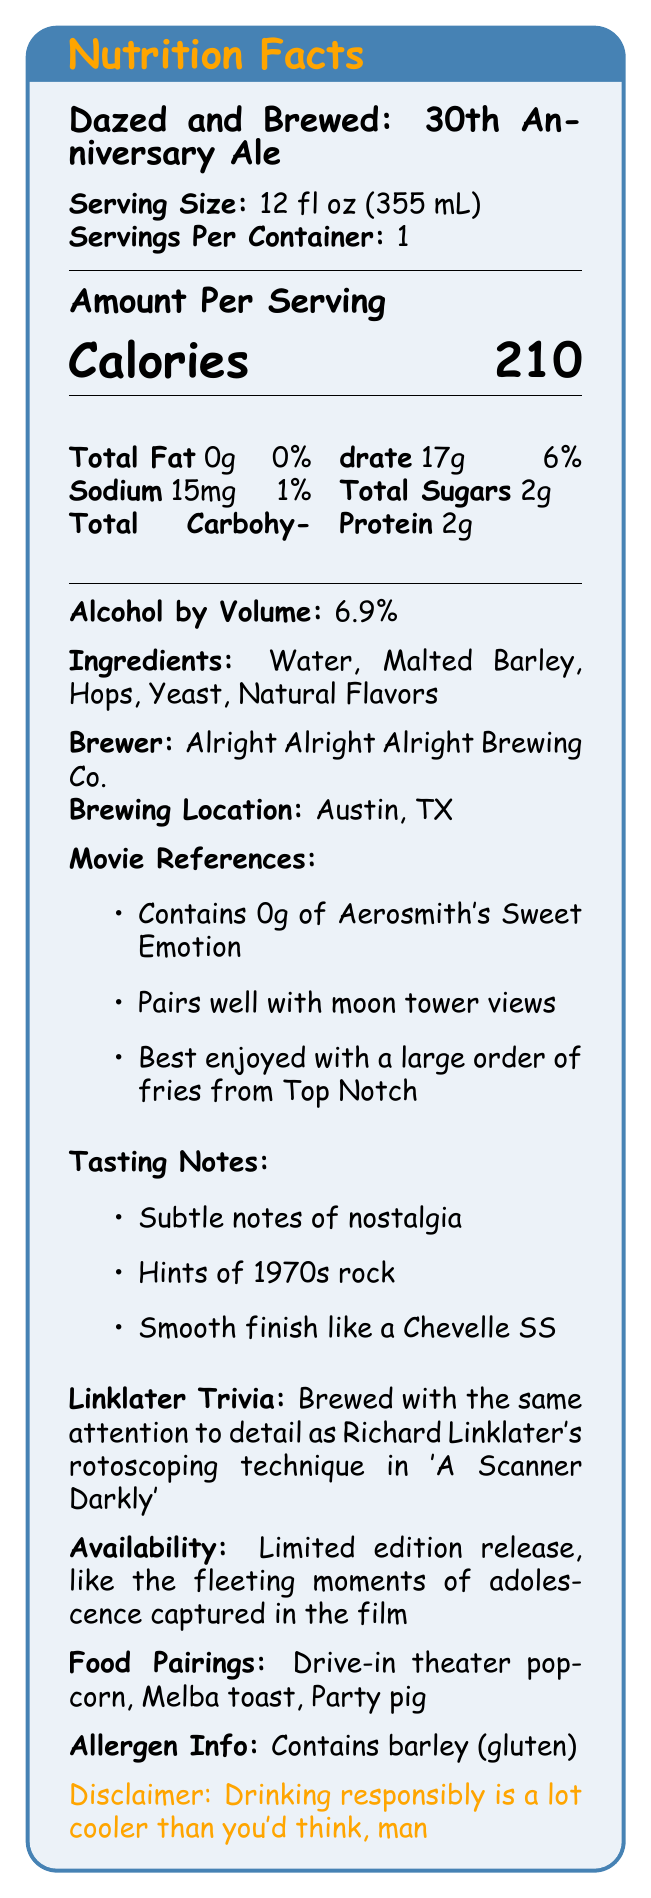what is the serving size for "Dazed and Brewed: 30th Anniversary Ale"? The serving size is listed as "12 fl oz (355 mL)" in the document under the section "Serving Size".
Answer: 12 fl oz (355 mL) how many servings are in each container of this craft beer? The document states that there is 1 serving per container under the section "Servings Per Container".
Answer: 1 how many calories are in one serving of "Dazed and Brewed: 30th Anniversary Ale"? The number of calories is shown in large font under the section "Amount Per Serving".
Answer: 210 what are the ingredients of this craft beer? The ingredients are listed under the section "Ingredients".
Answer: Water, Malted Barley, Hops, Yeast, Natural Flavors who is the brewer of "Dazed and Brewed: 30th Anniversary Ale"? The brewer is listed under the section "Brewer".
Answer: Alright Alright Alright Brewing Co. what is the alcohol by volume (ABV) of this ale? A. 5.0% B. 6.9% C. 7.5% The alcohol by volume is listed as 6.9% in the document under the section "Alcohol by Volume".
Answer: B which city is "Dazed and Brewed: 30th Anniversary Ale" brewed in? A. Houston, TX B. Dallas, TX C. Austin, TX The brewing location is listed as Austin, TX under the section "Brewing Location".
Answer: C which movie reference is not mentioned for this beer? A. Pairs well with moon tower views B. Best enjoyed with a large order of fries from Top Notch C. Supports skipping school for senior prank day Only the first two options are mentioned under "Movie References".
Answer: C contains this product any gluten? The allergen information states "Contains barley (gluten)".
Answer: Yes can we tell the specific brewing process used for this ale from the document? The document doesn't provide details on the specific brewing process used.
Answer: Cannot be determined describe the main idea of the document The document aims to celebrate the 30th anniversary of "Dazed and Confused" by providing detailed information on a themed craft beer produced by Alright Alright Alright Brewing Co.
Answer: The document provides comprehensive information about "Dazed and Brewed: 30th Anniversary Ale," including its nutrition facts, ingredients, brewing details, movie references, tasting notes, Linklater trivia, availability, food pairings, allergen information, and a responsible drinking disclaimer. is it recommended to drink "Dazed and Brewed: 30th Anniversary Ale" responsibly? The disclaimer section states, "Drinking responsibly is a lot cooler than you'd think, man."
Answer: Yes 